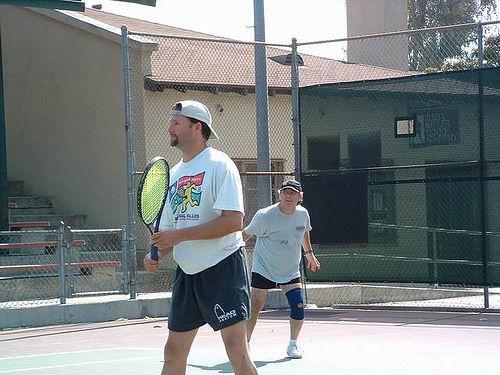How many hats are being worn backwards?
Keep it brief. 1. What is on the man's knee?
Give a very brief answer. Brace. Is it sunny?
Concise answer only. Yes. 